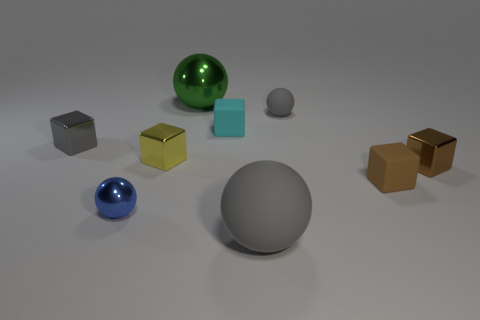What is the material of the small cube that is the same color as the large rubber ball?
Your answer should be very brief. Metal. What number of objects are large gray objects or big green balls?
Provide a short and direct response. 2. What is the material of the yellow block that is the same size as the brown rubber cube?
Provide a short and direct response. Metal. What is the size of the brown metallic cube right of the tiny gray metallic thing?
Your answer should be compact. Small. What is the green ball made of?
Offer a very short reply. Metal. How many things are either rubber spheres behind the small shiny sphere or small metallic objects that are to the right of the big metal ball?
Ensure brevity in your answer.  2. How many other objects are there of the same color as the big matte thing?
Provide a short and direct response. 2. Do the small gray matte object and the tiny rubber object on the left side of the big gray thing have the same shape?
Your answer should be very brief. No. Is the number of tiny gray rubber balls that are behind the large metallic thing less than the number of brown rubber objects that are behind the gray cube?
Provide a short and direct response. No. What is the material of the other small brown object that is the same shape as the brown shiny thing?
Ensure brevity in your answer.  Rubber. 